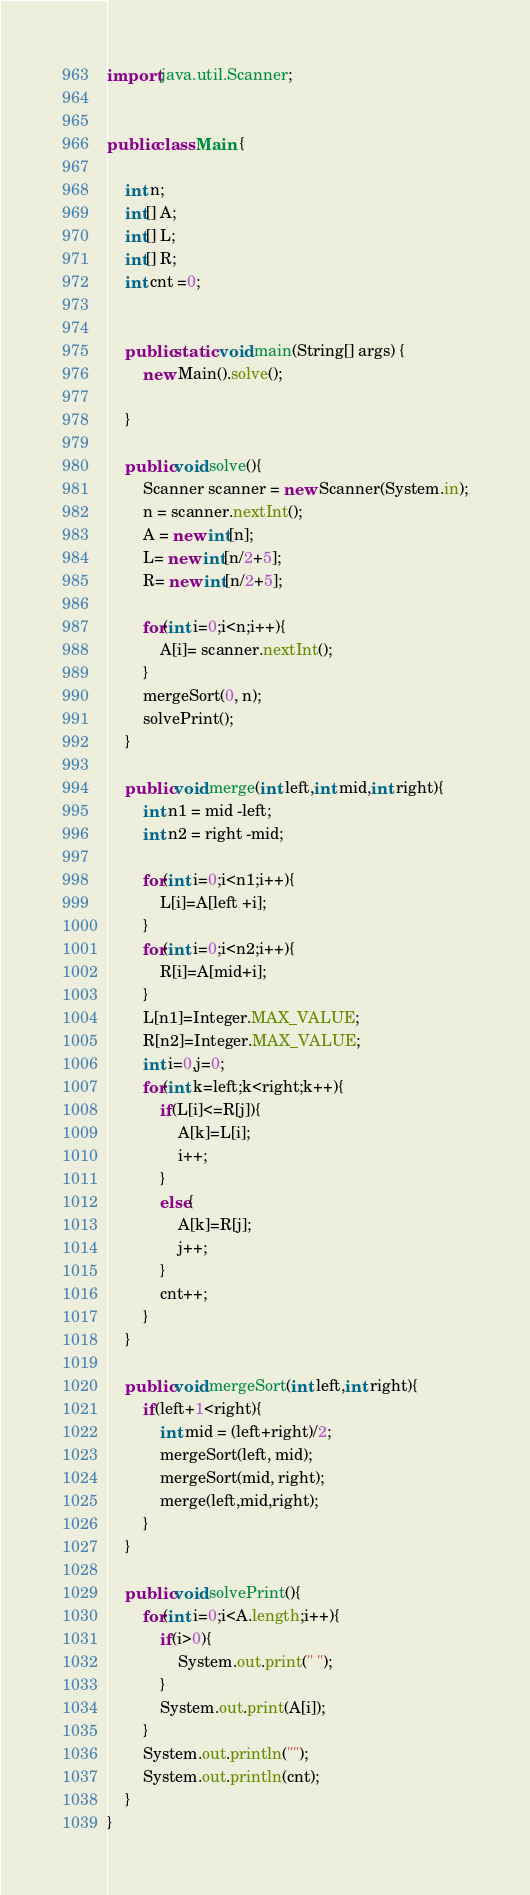Convert code to text. <code><loc_0><loc_0><loc_500><loc_500><_Java_>import java.util.Scanner;


public class Main {
	
	int n;
	int[] A;
	int[] L;
	int[] R;
	int cnt =0;
	
	
	public static void main(String[] args) {
		new Main().solve();
		
	}
	
	public void solve(){
		Scanner scanner = new Scanner(System.in);
		n = scanner.nextInt();
		A = new int[n];
		L= new int[n/2+5];
		R= new int[n/2+5];
		
		for(int i=0;i<n;i++){
			A[i]= scanner.nextInt();
		}
		mergeSort(0, n);
		solvePrint();
	}
	
	public void merge(int left,int mid,int right){
		int n1 = mid -left;
		int n2 = right -mid;
		
		for(int i=0;i<n1;i++){
			L[i]=A[left +i];
		}
		for(int i=0;i<n2;i++){
			R[i]=A[mid+i];
		}
		L[n1]=Integer.MAX_VALUE;
		R[n2]=Integer.MAX_VALUE;
		int i=0,j=0;
		for(int k=left;k<right;k++){
			if(L[i]<=R[j]){
				A[k]=L[i];
				i++;
			}
			else{
				A[k]=R[j];
				j++;
			}
			cnt++;
		}
	}
	
	public void mergeSort(int left,int right){
		if(left+1<right){
			int mid = (left+right)/2;
			mergeSort(left, mid);
			mergeSort(mid, right);
			merge(left,mid,right);
		}
	}
	
	public void solvePrint(){
		for(int i=0;i<A.length;i++){
			if(i>0){
				System.out.print(" ");
			}
			System.out.print(A[i]);
		}
		System.out.println("");
		System.out.println(cnt);
	}
}</code> 